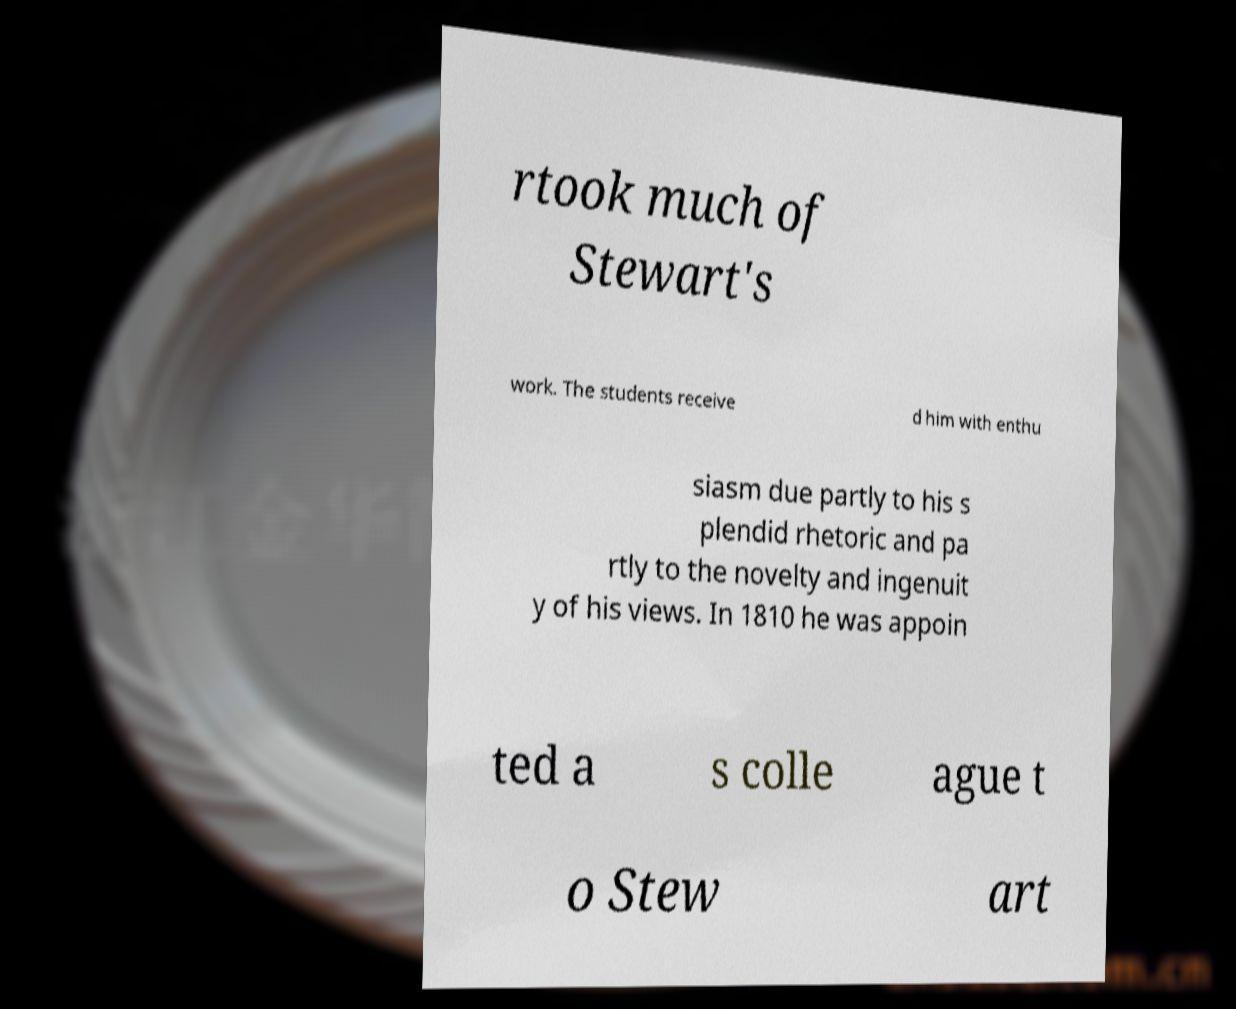Could you assist in decoding the text presented in this image and type it out clearly? rtook much of Stewart's work. The students receive d him with enthu siasm due partly to his s plendid rhetoric and pa rtly to the novelty and ingenuit y of his views. In 1810 he was appoin ted a s colle ague t o Stew art 